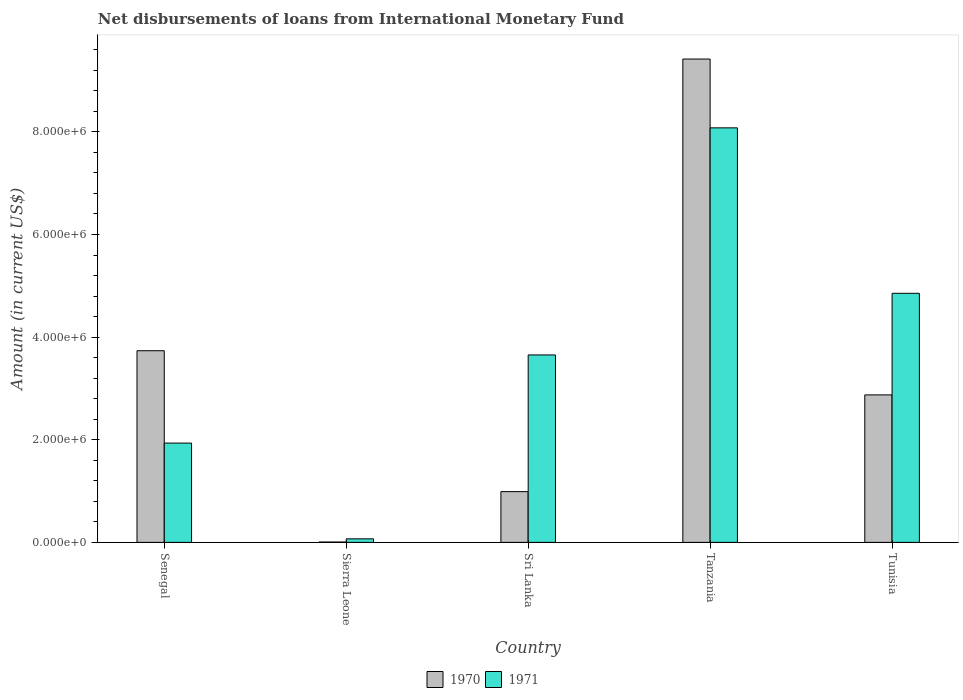How many different coloured bars are there?
Give a very brief answer. 2. How many groups of bars are there?
Provide a short and direct response. 5. Are the number of bars per tick equal to the number of legend labels?
Keep it short and to the point. Yes. How many bars are there on the 2nd tick from the left?
Make the answer very short. 2. What is the label of the 4th group of bars from the left?
Offer a very short reply. Tanzania. In how many cases, is the number of bars for a given country not equal to the number of legend labels?
Keep it short and to the point. 0. What is the amount of loans disbursed in 1970 in Tanzania?
Offer a terse response. 9.42e+06. Across all countries, what is the maximum amount of loans disbursed in 1971?
Offer a very short reply. 8.08e+06. Across all countries, what is the minimum amount of loans disbursed in 1970?
Offer a very short reply. 7000. In which country was the amount of loans disbursed in 1971 maximum?
Offer a very short reply. Tanzania. In which country was the amount of loans disbursed in 1971 minimum?
Your answer should be very brief. Sierra Leone. What is the total amount of loans disbursed in 1970 in the graph?
Offer a terse response. 1.70e+07. What is the difference between the amount of loans disbursed in 1970 in Sierra Leone and that in Tunisia?
Give a very brief answer. -2.87e+06. What is the difference between the amount of loans disbursed in 1971 in Senegal and the amount of loans disbursed in 1970 in Sierra Leone?
Your response must be concise. 1.93e+06. What is the average amount of loans disbursed in 1971 per country?
Provide a succinct answer. 3.72e+06. What is the difference between the amount of loans disbursed of/in 1970 and amount of loans disbursed of/in 1971 in Sri Lanka?
Your response must be concise. -2.66e+06. In how many countries, is the amount of loans disbursed in 1970 greater than 2400000 US$?
Your response must be concise. 3. What is the ratio of the amount of loans disbursed in 1970 in Sierra Leone to that in Tunisia?
Your answer should be compact. 0. What is the difference between the highest and the second highest amount of loans disbursed in 1971?
Offer a very short reply. 4.42e+06. What is the difference between the highest and the lowest amount of loans disbursed in 1971?
Keep it short and to the point. 8.01e+06. In how many countries, is the amount of loans disbursed in 1970 greater than the average amount of loans disbursed in 1970 taken over all countries?
Ensure brevity in your answer.  2. Is the sum of the amount of loans disbursed in 1971 in Senegal and Tunisia greater than the maximum amount of loans disbursed in 1970 across all countries?
Your response must be concise. No. How many bars are there?
Keep it short and to the point. 10. Are all the bars in the graph horizontal?
Provide a succinct answer. No. How many countries are there in the graph?
Provide a short and direct response. 5. Are the values on the major ticks of Y-axis written in scientific E-notation?
Provide a succinct answer. Yes. Does the graph contain grids?
Give a very brief answer. No. How many legend labels are there?
Provide a short and direct response. 2. How are the legend labels stacked?
Your answer should be very brief. Horizontal. What is the title of the graph?
Offer a very short reply. Net disbursements of loans from International Monetary Fund. What is the label or title of the X-axis?
Your answer should be compact. Country. What is the Amount (in current US$) in 1970 in Senegal?
Offer a very short reply. 3.74e+06. What is the Amount (in current US$) of 1971 in Senegal?
Offer a terse response. 1.94e+06. What is the Amount (in current US$) in 1970 in Sierra Leone?
Make the answer very short. 7000. What is the Amount (in current US$) in 1971 in Sierra Leone?
Ensure brevity in your answer.  6.90e+04. What is the Amount (in current US$) in 1970 in Sri Lanka?
Your answer should be very brief. 9.89e+05. What is the Amount (in current US$) in 1971 in Sri Lanka?
Your response must be concise. 3.65e+06. What is the Amount (in current US$) in 1970 in Tanzania?
Offer a very short reply. 9.42e+06. What is the Amount (in current US$) of 1971 in Tanzania?
Your response must be concise. 8.08e+06. What is the Amount (in current US$) in 1970 in Tunisia?
Ensure brevity in your answer.  2.87e+06. What is the Amount (in current US$) in 1971 in Tunisia?
Give a very brief answer. 4.85e+06. Across all countries, what is the maximum Amount (in current US$) in 1970?
Your answer should be compact. 9.42e+06. Across all countries, what is the maximum Amount (in current US$) of 1971?
Provide a short and direct response. 8.08e+06. Across all countries, what is the minimum Amount (in current US$) of 1970?
Offer a terse response. 7000. Across all countries, what is the minimum Amount (in current US$) of 1971?
Provide a succinct answer. 6.90e+04. What is the total Amount (in current US$) of 1970 in the graph?
Give a very brief answer. 1.70e+07. What is the total Amount (in current US$) of 1971 in the graph?
Provide a short and direct response. 1.86e+07. What is the difference between the Amount (in current US$) of 1970 in Senegal and that in Sierra Leone?
Your response must be concise. 3.73e+06. What is the difference between the Amount (in current US$) of 1971 in Senegal and that in Sierra Leone?
Keep it short and to the point. 1.87e+06. What is the difference between the Amount (in current US$) of 1970 in Senegal and that in Sri Lanka?
Ensure brevity in your answer.  2.75e+06. What is the difference between the Amount (in current US$) of 1971 in Senegal and that in Sri Lanka?
Your response must be concise. -1.72e+06. What is the difference between the Amount (in current US$) in 1970 in Senegal and that in Tanzania?
Offer a terse response. -5.68e+06. What is the difference between the Amount (in current US$) in 1971 in Senegal and that in Tanzania?
Offer a very short reply. -6.14e+06. What is the difference between the Amount (in current US$) of 1970 in Senegal and that in Tunisia?
Provide a succinct answer. 8.61e+05. What is the difference between the Amount (in current US$) of 1971 in Senegal and that in Tunisia?
Give a very brief answer. -2.92e+06. What is the difference between the Amount (in current US$) in 1970 in Sierra Leone and that in Sri Lanka?
Make the answer very short. -9.82e+05. What is the difference between the Amount (in current US$) of 1971 in Sierra Leone and that in Sri Lanka?
Keep it short and to the point. -3.58e+06. What is the difference between the Amount (in current US$) of 1970 in Sierra Leone and that in Tanzania?
Keep it short and to the point. -9.41e+06. What is the difference between the Amount (in current US$) of 1971 in Sierra Leone and that in Tanzania?
Offer a terse response. -8.01e+06. What is the difference between the Amount (in current US$) in 1970 in Sierra Leone and that in Tunisia?
Offer a terse response. -2.87e+06. What is the difference between the Amount (in current US$) of 1971 in Sierra Leone and that in Tunisia?
Offer a terse response. -4.78e+06. What is the difference between the Amount (in current US$) in 1970 in Sri Lanka and that in Tanzania?
Give a very brief answer. -8.43e+06. What is the difference between the Amount (in current US$) of 1971 in Sri Lanka and that in Tanzania?
Ensure brevity in your answer.  -4.42e+06. What is the difference between the Amount (in current US$) in 1970 in Sri Lanka and that in Tunisia?
Your response must be concise. -1.88e+06. What is the difference between the Amount (in current US$) in 1971 in Sri Lanka and that in Tunisia?
Offer a terse response. -1.20e+06. What is the difference between the Amount (in current US$) of 1970 in Tanzania and that in Tunisia?
Ensure brevity in your answer.  6.54e+06. What is the difference between the Amount (in current US$) in 1971 in Tanzania and that in Tunisia?
Your answer should be compact. 3.22e+06. What is the difference between the Amount (in current US$) in 1970 in Senegal and the Amount (in current US$) in 1971 in Sierra Leone?
Provide a succinct answer. 3.67e+06. What is the difference between the Amount (in current US$) of 1970 in Senegal and the Amount (in current US$) of 1971 in Sri Lanka?
Your answer should be very brief. 8.20e+04. What is the difference between the Amount (in current US$) of 1970 in Senegal and the Amount (in current US$) of 1971 in Tanzania?
Your response must be concise. -4.34e+06. What is the difference between the Amount (in current US$) of 1970 in Senegal and the Amount (in current US$) of 1971 in Tunisia?
Offer a terse response. -1.12e+06. What is the difference between the Amount (in current US$) in 1970 in Sierra Leone and the Amount (in current US$) in 1971 in Sri Lanka?
Ensure brevity in your answer.  -3.65e+06. What is the difference between the Amount (in current US$) in 1970 in Sierra Leone and the Amount (in current US$) in 1971 in Tanzania?
Ensure brevity in your answer.  -8.07e+06. What is the difference between the Amount (in current US$) of 1970 in Sierra Leone and the Amount (in current US$) of 1971 in Tunisia?
Provide a succinct answer. -4.85e+06. What is the difference between the Amount (in current US$) of 1970 in Sri Lanka and the Amount (in current US$) of 1971 in Tanzania?
Give a very brief answer. -7.09e+06. What is the difference between the Amount (in current US$) of 1970 in Sri Lanka and the Amount (in current US$) of 1971 in Tunisia?
Make the answer very short. -3.86e+06. What is the difference between the Amount (in current US$) of 1970 in Tanzania and the Amount (in current US$) of 1971 in Tunisia?
Your answer should be very brief. 4.56e+06. What is the average Amount (in current US$) of 1970 per country?
Provide a succinct answer. 3.40e+06. What is the average Amount (in current US$) of 1971 per country?
Offer a very short reply. 3.72e+06. What is the difference between the Amount (in current US$) of 1970 and Amount (in current US$) of 1971 in Senegal?
Provide a succinct answer. 1.80e+06. What is the difference between the Amount (in current US$) in 1970 and Amount (in current US$) in 1971 in Sierra Leone?
Your response must be concise. -6.20e+04. What is the difference between the Amount (in current US$) in 1970 and Amount (in current US$) in 1971 in Sri Lanka?
Provide a succinct answer. -2.66e+06. What is the difference between the Amount (in current US$) in 1970 and Amount (in current US$) in 1971 in Tanzania?
Your answer should be very brief. 1.34e+06. What is the difference between the Amount (in current US$) of 1970 and Amount (in current US$) of 1971 in Tunisia?
Your response must be concise. -1.98e+06. What is the ratio of the Amount (in current US$) of 1970 in Senegal to that in Sierra Leone?
Provide a short and direct response. 533.57. What is the ratio of the Amount (in current US$) of 1971 in Senegal to that in Sierra Leone?
Keep it short and to the point. 28.04. What is the ratio of the Amount (in current US$) in 1970 in Senegal to that in Sri Lanka?
Provide a short and direct response. 3.78. What is the ratio of the Amount (in current US$) in 1971 in Senegal to that in Sri Lanka?
Ensure brevity in your answer.  0.53. What is the ratio of the Amount (in current US$) of 1970 in Senegal to that in Tanzania?
Your answer should be compact. 0.4. What is the ratio of the Amount (in current US$) of 1971 in Senegal to that in Tanzania?
Offer a terse response. 0.24. What is the ratio of the Amount (in current US$) of 1970 in Senegal to that in Tunisia?
Make the answer very short. 1.3. What is the ratio of the Amount (in current US$) in 1971 in Senegal to that in Tunisia?
Offer a very short reply. 0.4. What is the ratio of the Amount (in current US$) in 1970 in Sierra Leone to that in Sri Lanka?
Keep it short and to the point. 0.01. What is the ratio of the Amount (in current US$) in 1971 in Sierra Leone to that in Sri Lanka?
Provide a succinct answer. 0.02. What is the ratio of the Amount (in current US$) of 1970 in Sierra Leone to that in Tanzania?
Your answer should be compact. 0. What is the ratio of the Amount (in current US$) of 1971 in Sierra Leone to that in Tanzania?
Provide a short and direct response. 0.01. What is the ratio of the Amount (in current US$) of 1970 in Sierra Leone to that in Tunisia?
Give a very brief answer. 0. What is the ratio of the Amount (in current US$) of 1971 in Sierra Leone to that in Tunisia?
Provide a short and direct response. 0.01. What is the ratio of the Amount (in current US$) in 1970 in Sri Lanka to that in Tanzania?
Provide a succinct answer. 0.1. What is the ratio of the Amount (in current US$) in 1971 in Sri Lanka to that in Tanzania?
Your answer should be very brief. 0.45. What is the ratio of the Amount (in current US$) of 1970 in Sri Lanka to that in Tunisia?
Your answer should be very brief. 0.34. What is the ratio of the Amount (in current US$) of 1971 in Sri Lanka to that in Tunisia?
Give a very brief answer. 0.75. What is the ratio of the Amount (in current US$) in 1970 in Tanzania to that in Tunisia?
Your answer should be very brief. 3.28. What is the ratio of the Amount (in current US$) of 1971 in Tanzania to that in Tunisia?
Give a very brief answer. 1.66. What is the difference between the highest and the second highest Amount (in current US$) of 1970?
Your answer should be very brief. 5.68e+06. What is the difference between the highest and the second highest Amount (in current US$) of 1971?
Offer a terse response. 3.22e+06. What is the difference between the highest and the lowest Amount (in current US$) in 1970?
Provide a succinct answer. 9.41e+06. What is the difference between the highest and the lowest Amount (in current US$) of 1971?
Your answer should be compact. 8.01e+06. 